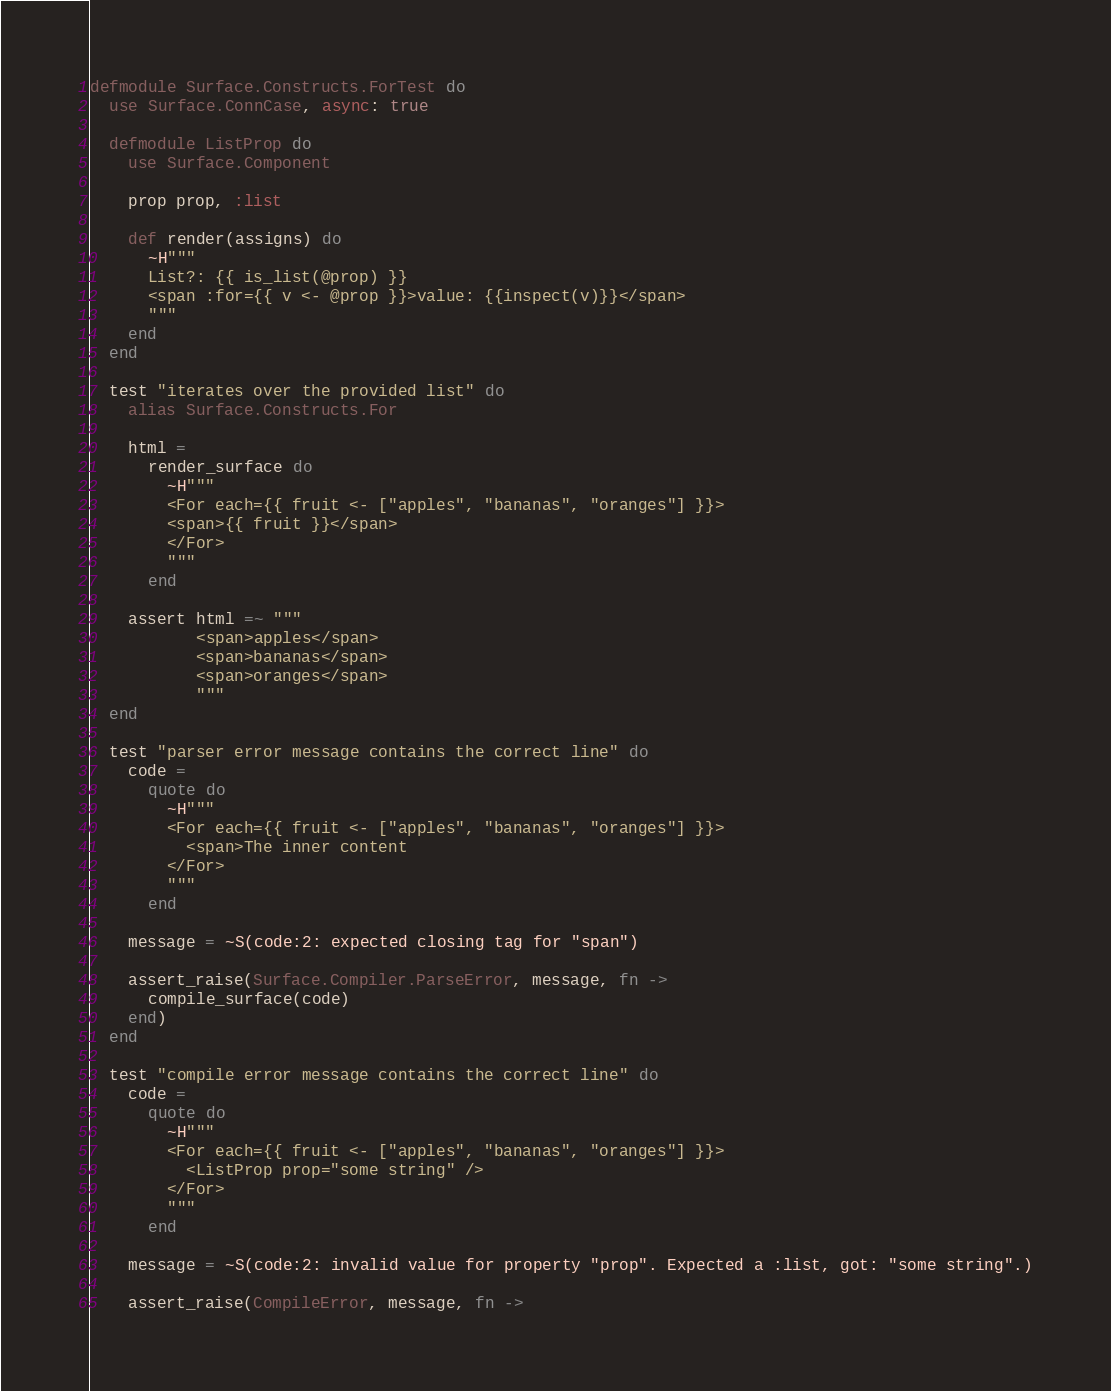<code> <loc_0><loc_0><loc_500><loc_500><_Elixir_>defmodule Surface.Constructs.ForTest do
  use Surface.ConnCase, async: true

  defmodule ListProp do
    use Surface.Component

    prop prop, :list

    def render(assigns) do
      ~H"""
      List?: {{ is_list(@prop) }}
      <span :for={{ v <- @prop }}>value: {{inspect(v)}}</span>
      """
    end
  end

  test "iterates over the provided list" do
    alias Surface.Constructs.For

    html =
      render_surface do
        ~H"""
        <For each={{ fruit <- ["apples", "bananas", "oranges"] }}>
        <span>{{ fruit }}</span>
        </For>
        """
      end

    assert html =~ """
           <span>apples</span>
           <span>bananas</span>
           <span>oranges</span>
           """
  end

  test "parser error message contains the correct line" do
    code =
      quote do
        ~H"""
        <For each={{ fruit <- ["apples", "bananas", "oranges"] }}>
          <span>The inner content
        </For>
        """
      end

    message = ~S(code:2: expected closing tag for "span")

    assert_raise(Surface.Compiler.ParseError, message, fn ->
      compile_surface(code)
    end)
  end

  test "compile error message contains the correct line" do
    code =
      quote do
        ~H"""
        <For each={{ fruit <- ["apples", "bananas", "oranges"] }}>
          <ListProp prop="some string" />
        </For>
        """
      end

    message = ~S(code:2: invalid value for property "prop". Expected a :list, got: "some string".)

    assert_raise(CompileError, message, fn -></code> 